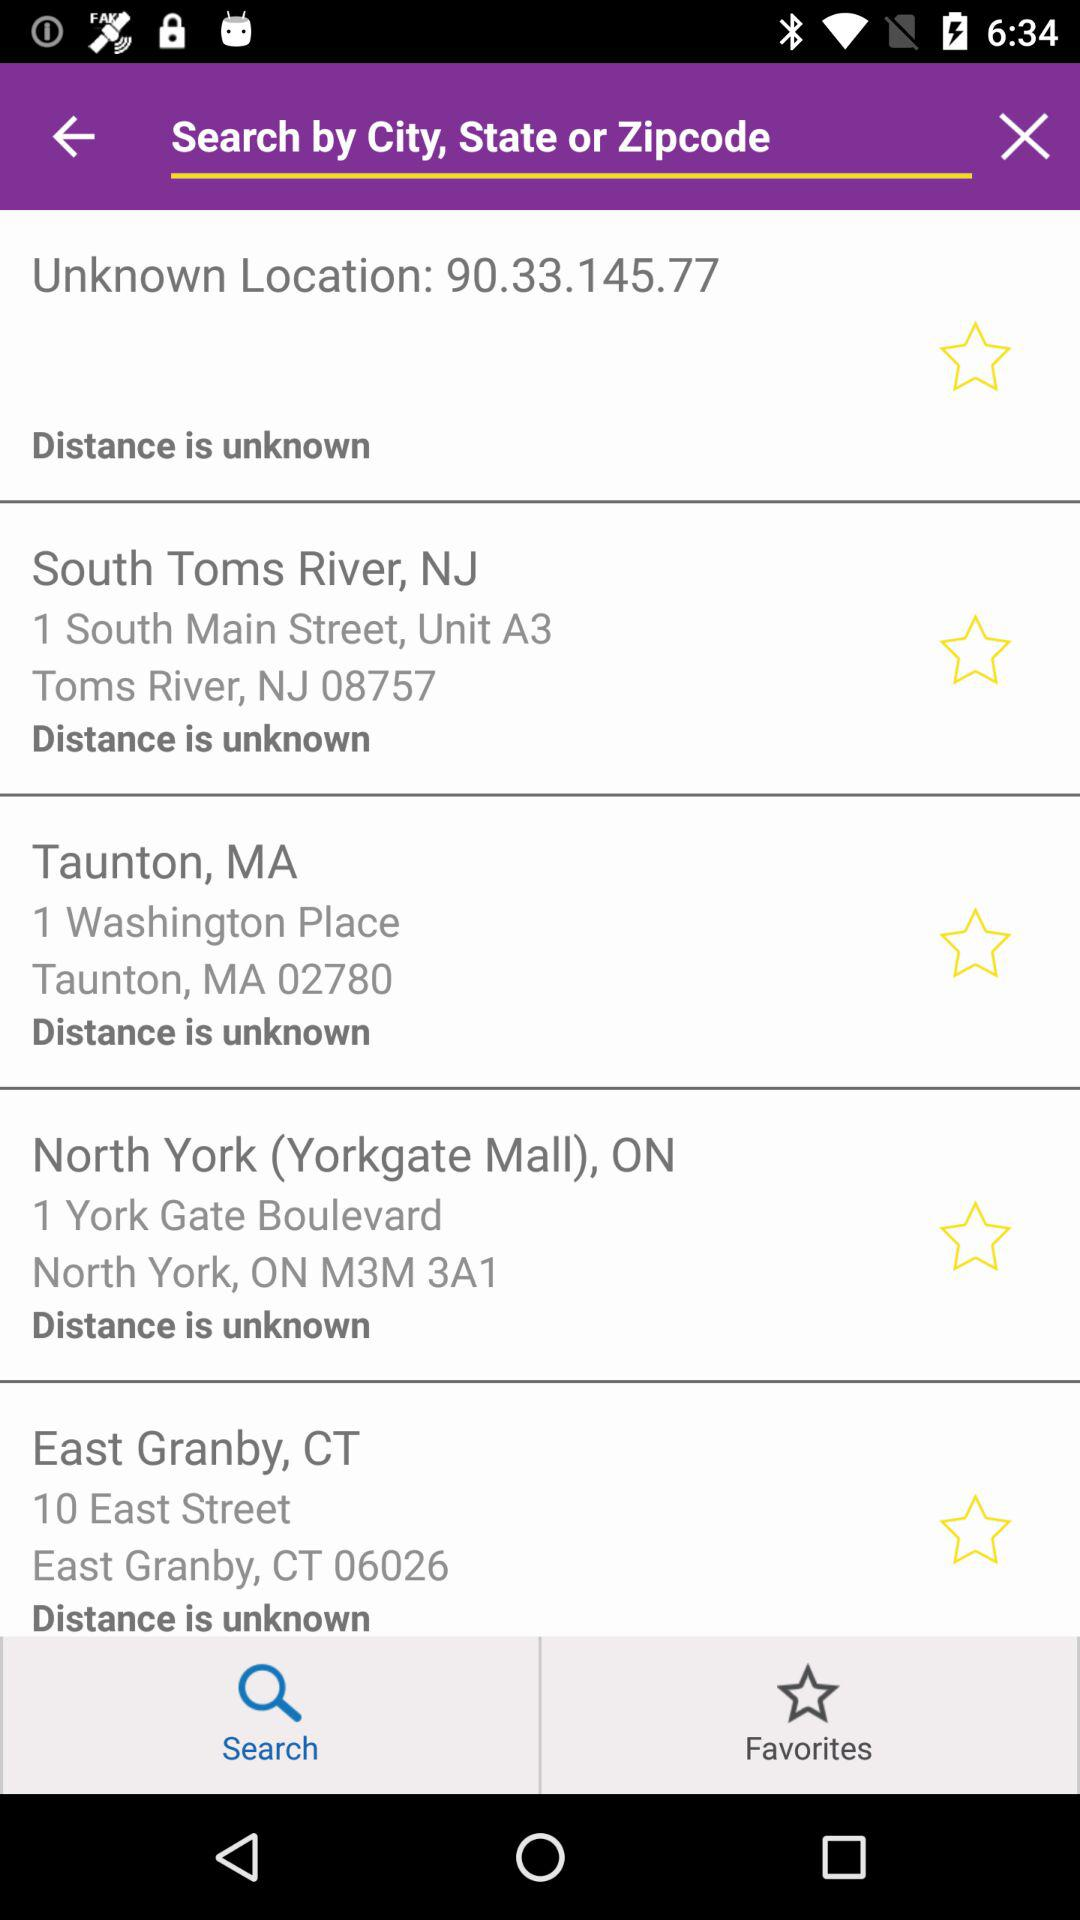Which tab am I using? You are using the "Search" tab. 